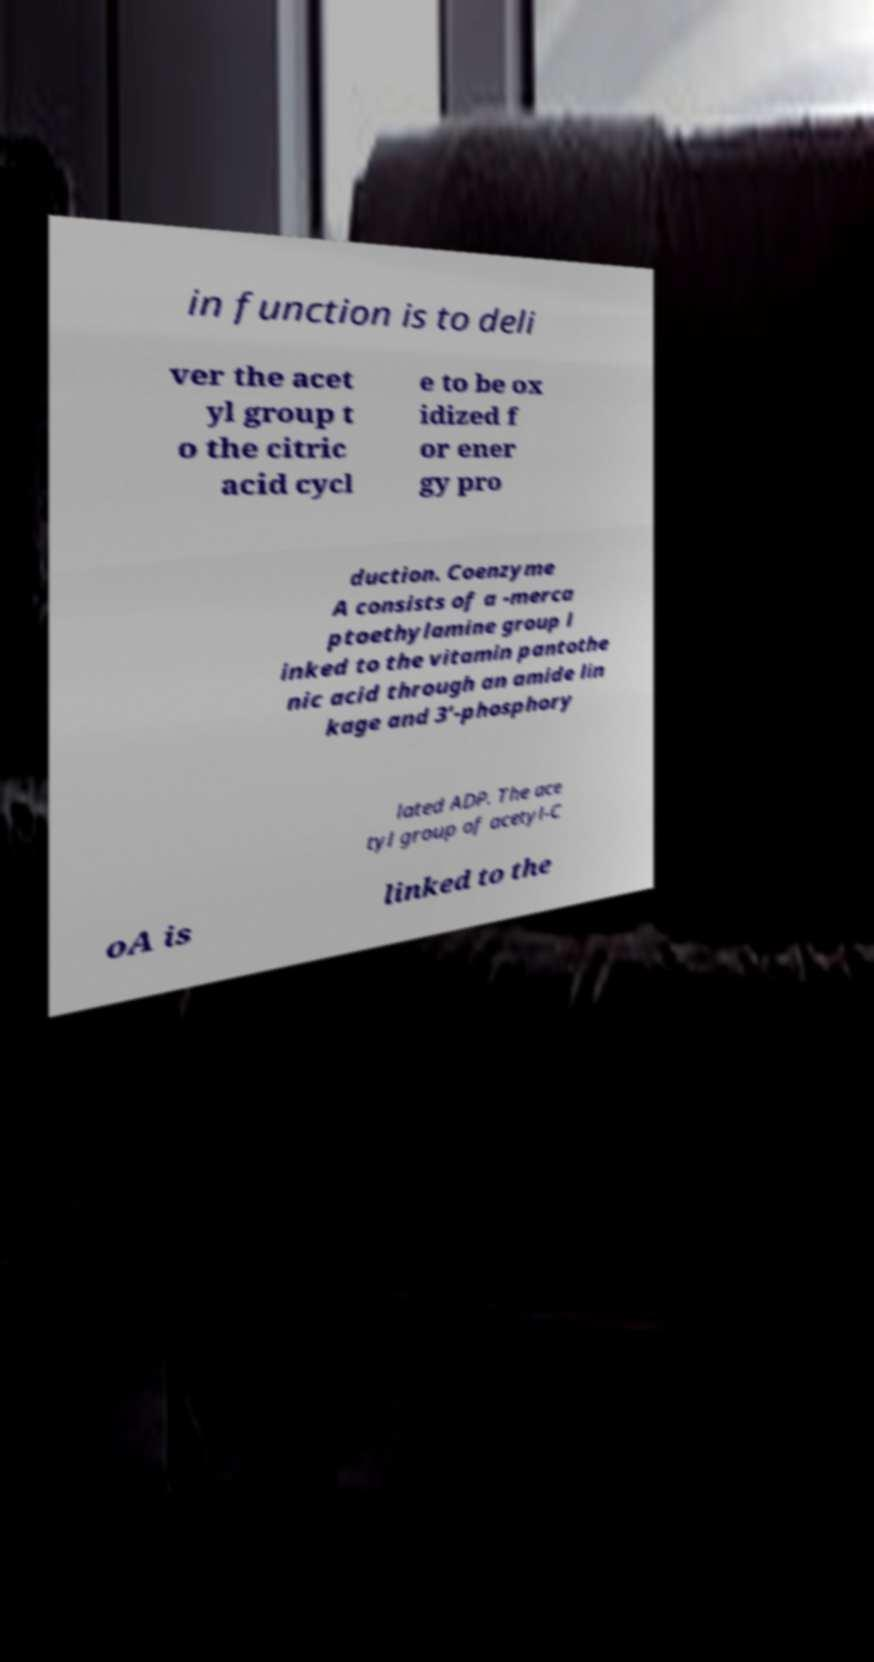Could you extract and type out the text from this image? in function is to deli ver the acet yl group t o the citric acid cycl e to be ox idized f or ener gy pro duction. Coenzyme A consists of a -merca ptoethylamine group l inked to the vitamin pantothe nic acid through an amide lin kage and 3'-phosphory lated ADP. The ace tyl group of acetyl-C oA is linked to the 